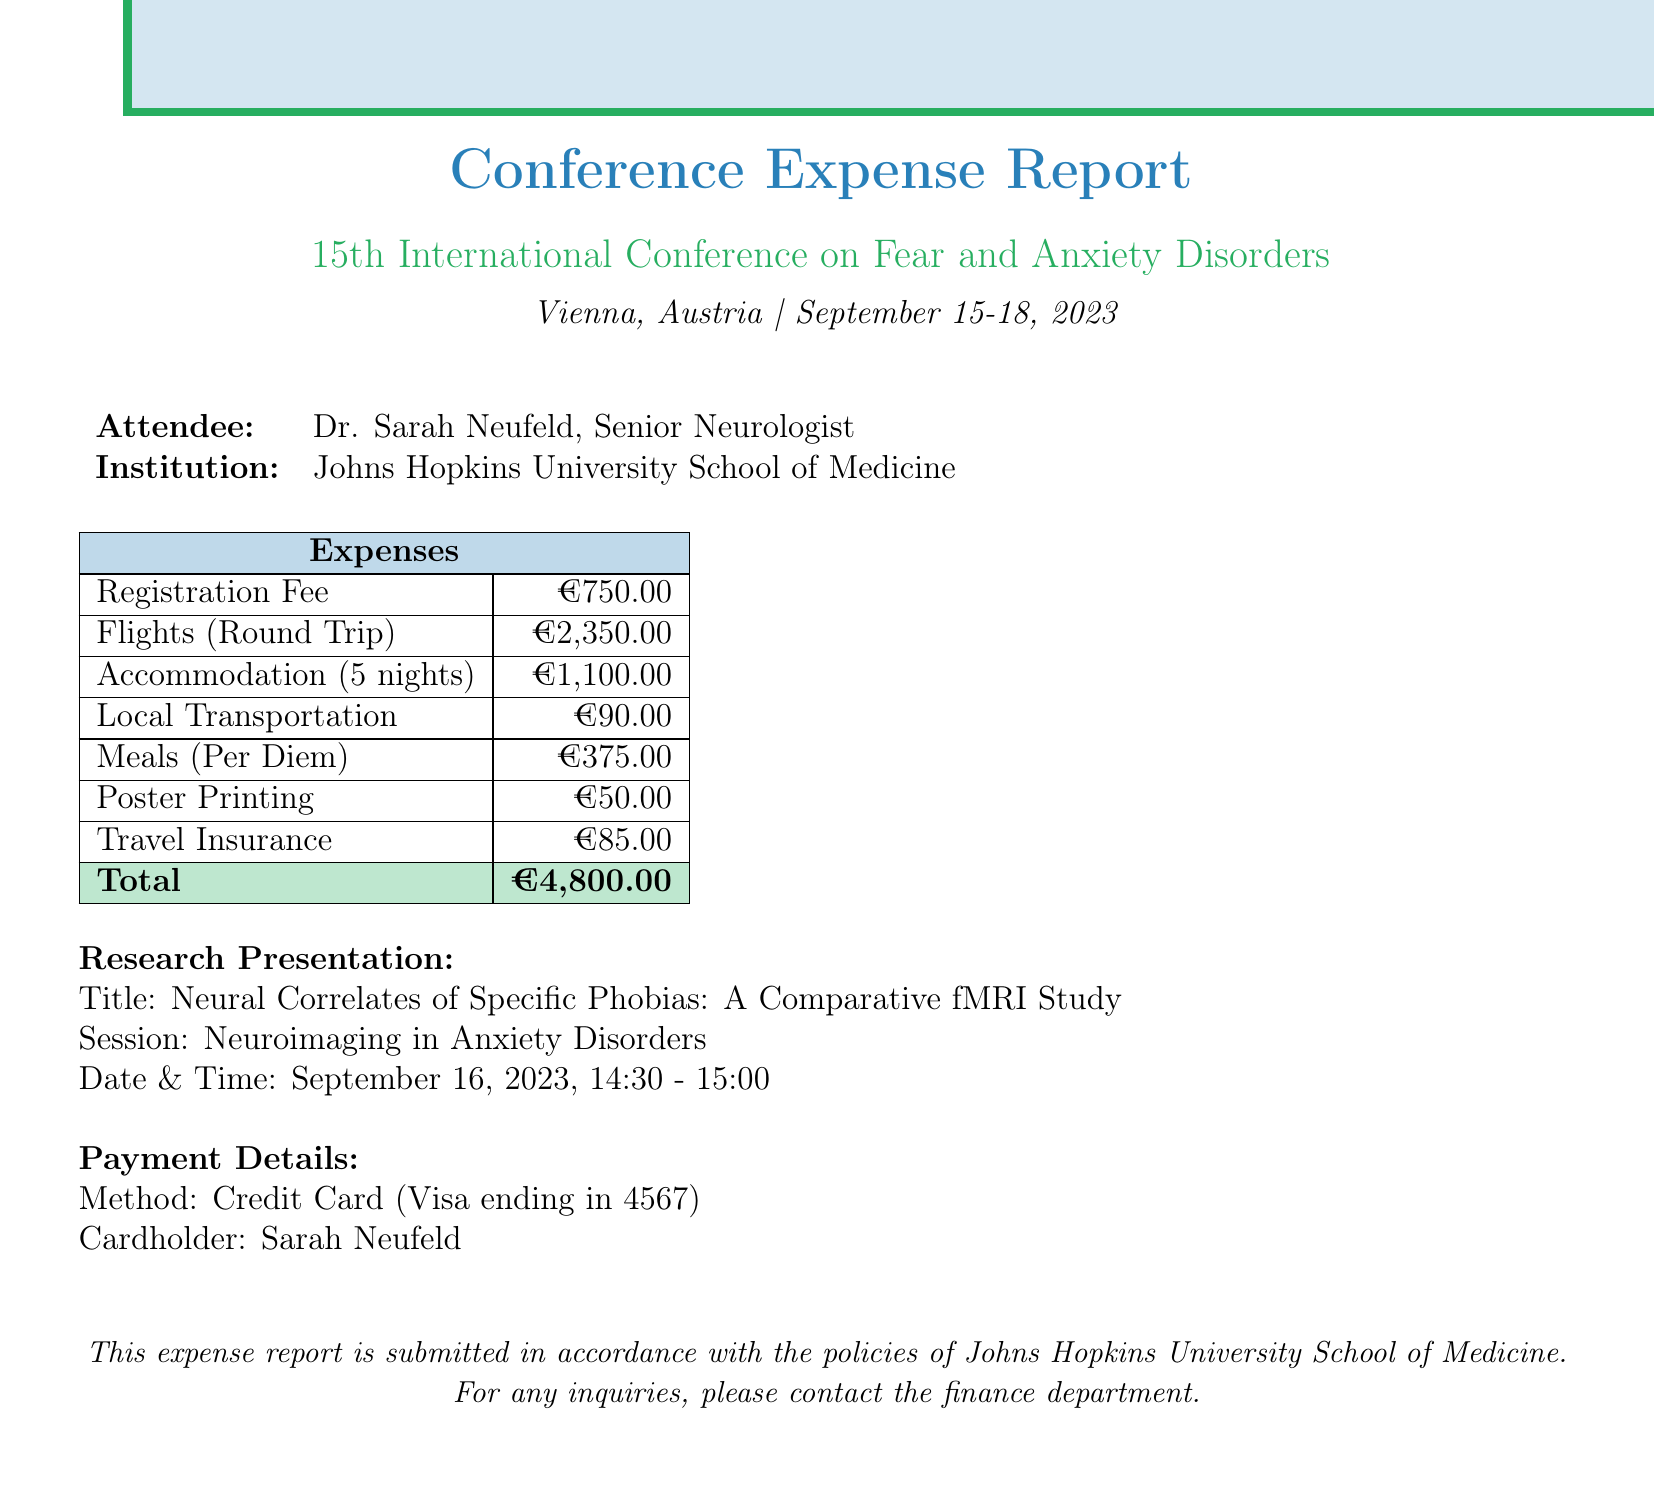What is the name of the conference? The conference name is mentioned in the document under conference_details, which states "15th International Conference on Fear and Anxiety Disorders."
Answer: 15th International Conference on Fear and Anxiety Disorders Who is the attendee? The document highlights the attendee's name and title under attendee_info, where it states, "Dr. Sarah Neufeld."
Answer: Dr. Sarah Neufeld What is the total cost of flights? The total cost of flights is summed from outbound and return flight costs provided in travel_expenses. It equals €1200 + €1150.
Answer: €2,350.00 How many nights did the attendee stay? The number of nights stayed is indicated in the accommodation details under travel_expenses, where it specifies "5 nights."
Answer: 5 nights What is the title of the research presentation? The title can be found under research_presentation and indicates the name of the study being presented.
Answer: Neural Correlates of Specific Phobias: A Comparative fMRI Study Which payment method was used? The payment method is specified in the payment_details section, identifying the credit card type used for the payment.
Answer: Credit Card How much is the registration fee? The registration fee is detailed under registration_fees within the document.
Answer: €750.00 What is included in the registration fee? The registration fee section lists several items that are included.
Answer: Access to all scientific sessions, Conference materials, Welcome reception, Coffee breaks, Lunch for 3 days What is the total amount of the expenses? The total amount is summarized at the end of the expense report table and is the aggregate of all costs listed.
Answer: €4,800.00 